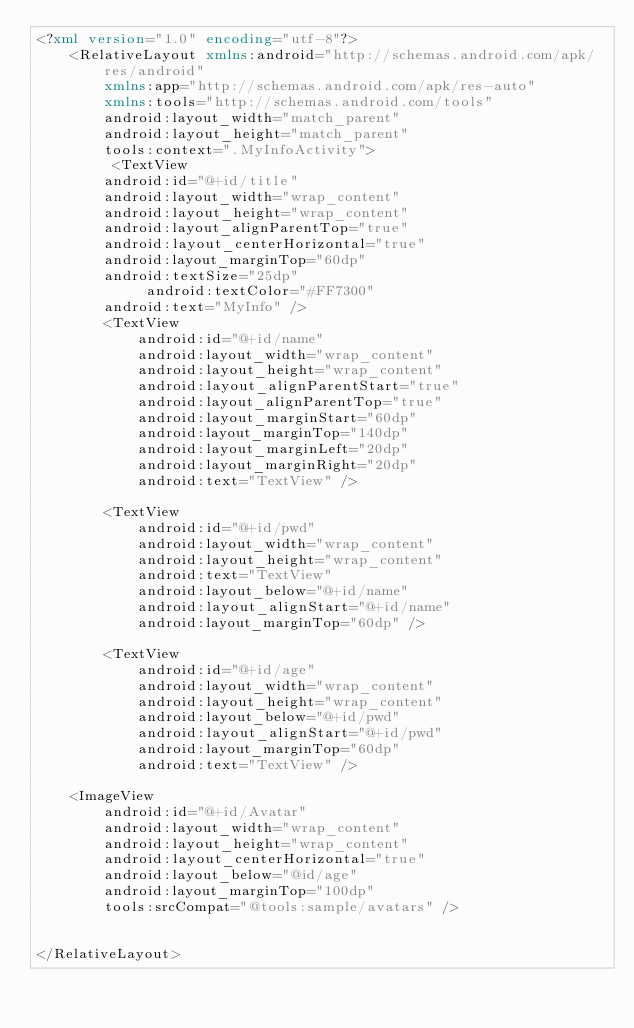Convert code to text. <code><loc_0><loc_0><loc_500><loc_500><_XML_><?xml version="1.0" encoding="utf-8"?>
    <RelativeLayout xmlns:android="http://schemas.android.com/apk/res/android"
        xmlns:app="http://schemas.android.com/apk/res-auto"
        xmlns:tools="http://schemas.android.com/tools"
        android:layout_width="match_parent"
        android:layout_height="match_parent"
        tools:context=".MyInfoActivity">
         <TextView
        android:id="@+id/title"
        android:layout_width="wrap_content"
        android:layout_height="wrap_content"
        android:layout_alignParentTop="true"
        android:layout_centerHorizontal="true"
        android:layout_marginTop="60dp"
        android:textSize="25dp"
             android:textColor="#FF7300"
        android:text="MyInfo" />
        <TextView
            android:id="@+id/name"
            android:layout_width="wrap_content"
            android:layout_height="wrap_content"
            android:layout_alignParentStart="true"
            android:layout_alignParentTop="true"
            android:layout_marginStart="60dp"
            android:layout_marginTop="140dp"
            android:layout_marginLeft="20dp"
            android:layout_marginRight="20dp"
            android:text="TextView" />

        <TextView
            android:id="@+id/pwd"
            android:layout_width="wrap_content"
            android:layout_height="wrap_content"
            android:text="TextView"
            android:layout_below="@+id/name"
            android:layout_alignStart="@+id/name"
            android:layout_marginTop="60dp" />

        <TextView
            android:id="@+id/age"
            android:layout_width="wrap_content"
            android:layout_height="wrap_content"
            android:layout_below="@+id/pwd"
            android:layout_alignStart="@+id/pwd"
            android:layout_marginTop="60dp"
            android:text="TextView" />

    <ImageView
        android:id="@+id/Avatar"
        android:layout_width="wrap_content"
        android:layout_height="wrap_content"
        android:layout_centerHorizontal="true"
        android:layout_below="@id/age"
        android:layout_marginTop="100dp"
        tools:srcCompat="@tools:sample/avatars" />


</RelativeLayout>
</code> 